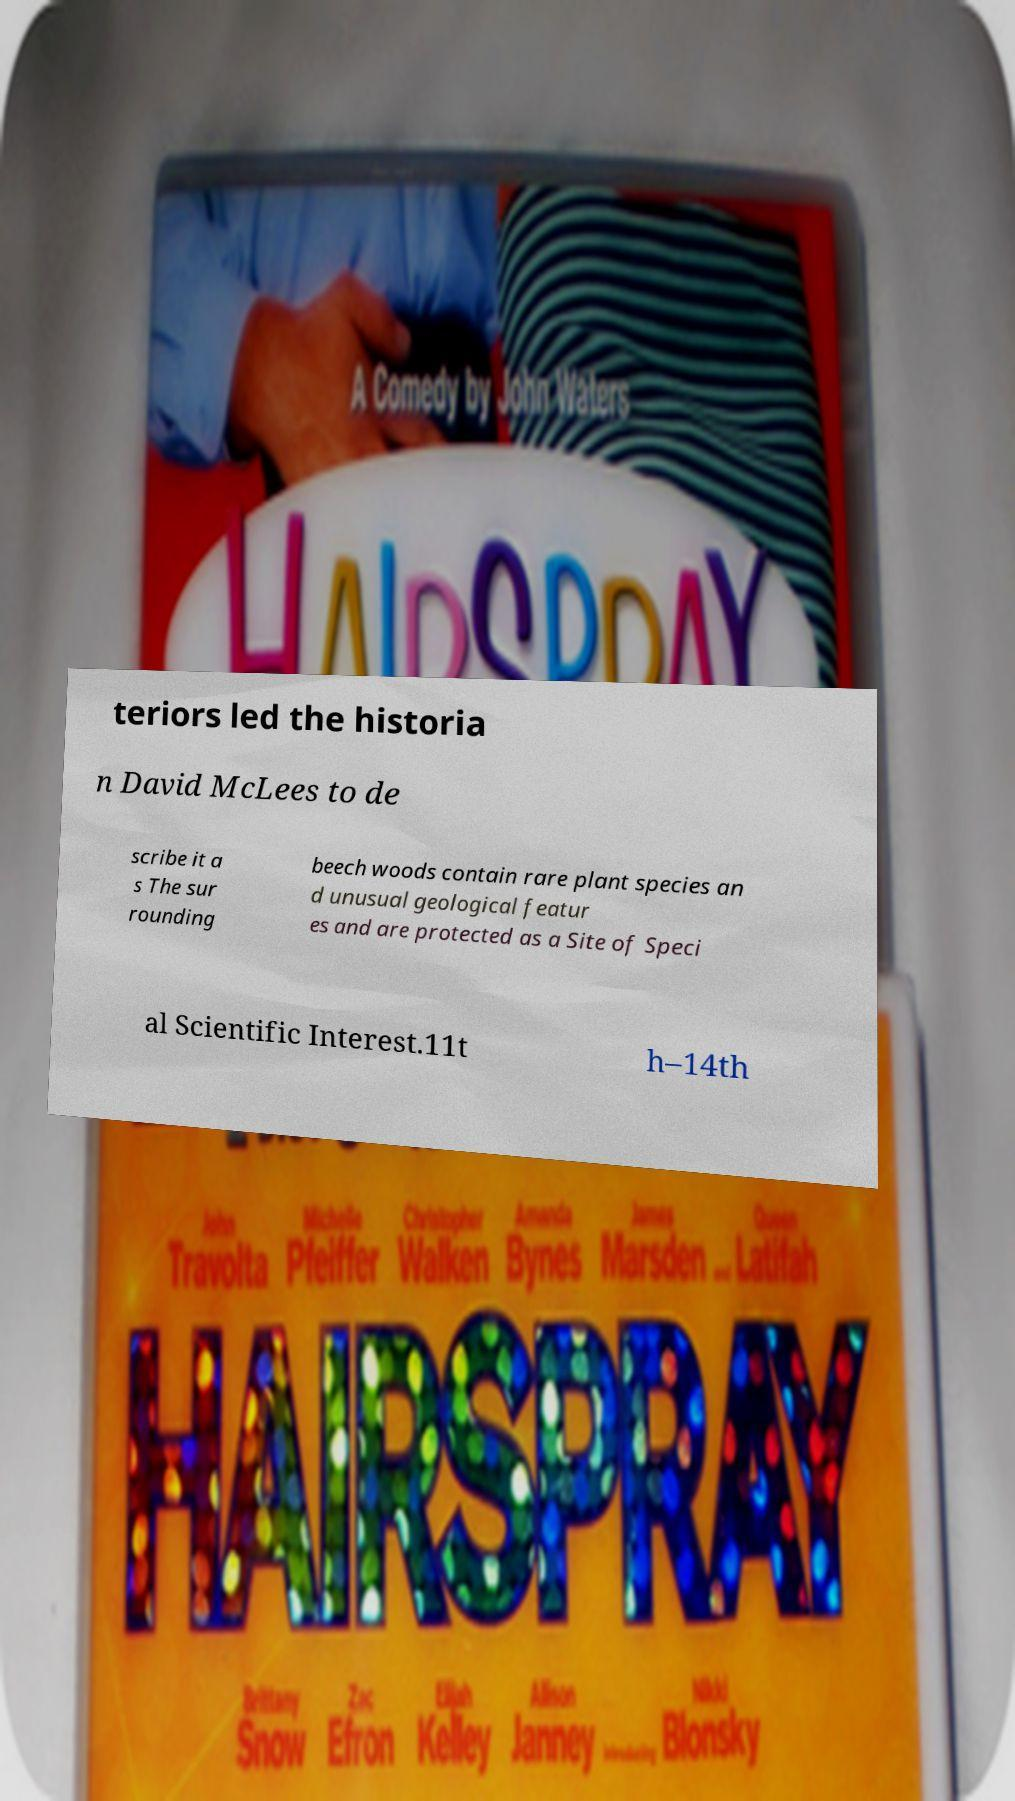What messages or text are displayed in this image? I need them in a readable, typed format. teriors led the historia n David McLees to de scribe it a s The sur rounding beech woods contain rare plant species an d unusual geological featur es and are protected as a Site of Speci al Scientific Interest.11t h–14th 